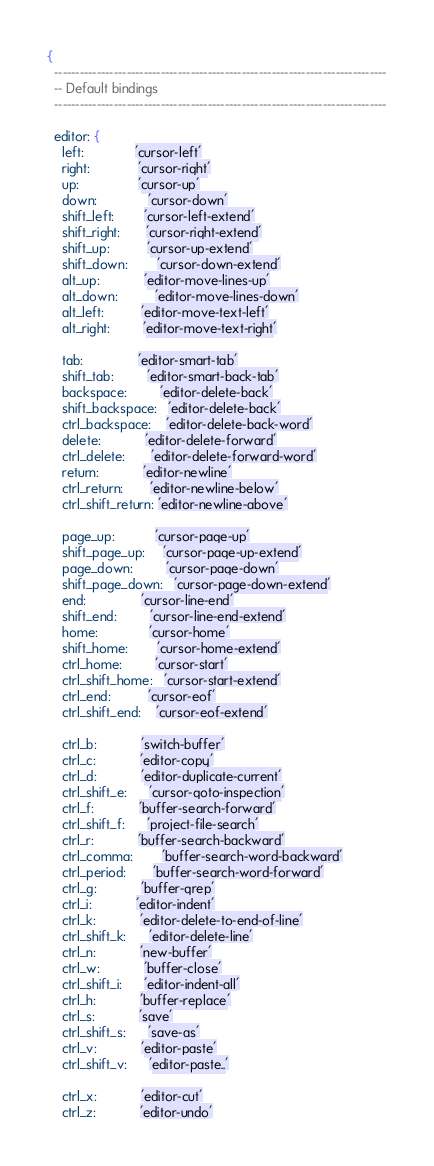<code> <loc_0><loc_0><loc_500><loc_500><_MoonScript_>{
  ------------------------------------------------------------------------------
  -- Default bindings
  ------------------------------------------------------------------------------

  editor: {
    left:              'cursor-left'
    right:             'cursor-right'
    up:                'cursor-up'
    down:              'cursor-down'
    shift_left:        'cursor-left-extend'
    shift_right:       'cursor-right-extend'
    shift_up:          'cursor-up-extend'
    shift_down:        'cursor-down-extend'
    alt_up:            'editor-move-lines-up'
    alt_down:          'editor-move-lines-down'
    alt_left:          'editor-move-text-left'
    alt_right:         'editor-move-text-right'

    tab:               'editor-smart-tab'
    shift_tab:         'editor-smart-back-tab'
    backspace:         'editor-delete-back'
    shift_backspace:   'editor-delete-back'
    ctrl_backspace:    'editor-delete-back-word'
    delete:            'editor-delete-forward'
    ctrl_delete:       'editor-delete-forward-word'
    return:            'editor-newline'
    ctrl_return:       'editor-newline-below'
    ctrl_shift_return: 'editor-newline-above'

    page_up:           'cursor-page-up'
    shift_page_up:     'cursor-page-up-extend'
    page_down:         'cursor-page-down'
    shift_page_down:   'cursor-page-down-extend'
    end:               'cursor-line-end'
    shift_end:         'cursor-line-end-extend'
    home:              'cursor-home'
    shift_home:        'cursor-home-extend'
    ctrl_home:         'cursor-start'
    ctrl_shift_home:   'cursor-start-extend'
    ctrl_end:          'cursor-eof'
    ctrl_shift_end:    'cursor-eof-extend'

    ctrl_b:            'switch-buffer'
    ctrl_c:            'editor-copy'
    ctrl_d:            'editor-duplicate-current'
    ctrl_shift_e:      'cursor-goto-inspection'
    ctrl_f:            'buffer-search-forward'
    ctrl_shift_f:      'project-file-search'
    ctrl_r:            'buffer-search-backward'
    ctrl_comma:        'buffer-search-word-backward'
    ctrl_period:       'buffer-search-word-forward'
    ctrl_g:            'buffer-grep'
    ctrl_i:            'editor-indent'
    ctrl_k:            'editor-delete-to-end-of-line'
    ctrl_shift_k:      'editor-delete-line'
    ctrl_n:            'new-buffer'
    ctrl_w:            'buffer-close'
    ctrl_shift_i:      'editor-indent-all'
    ctrl_h:            'buffer-replace'
    ctrl_s:            'save'
    ctrl_shift_s:      'save-as'
    ctrl_v:            'editor-paste'
    ctrl_shift_v:      'editor-paste..'

    ctrl_x:            'editor-cut'
    ctrl_z:            'editor-undo'</code> 